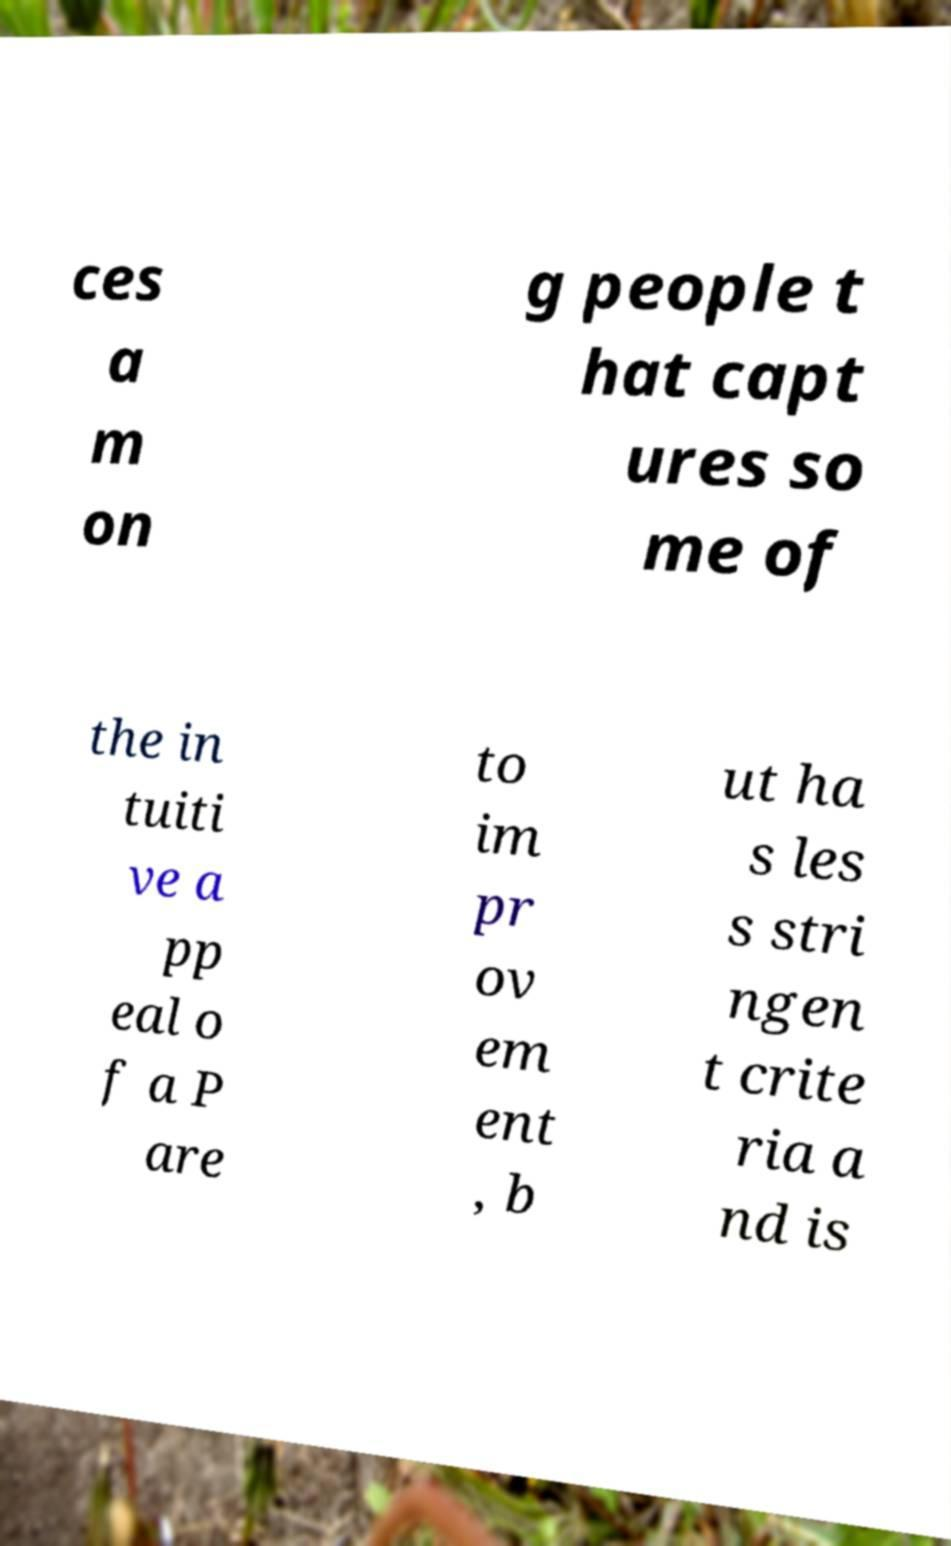Please identify and transcribe the text found in this image. ces a m on g people t hat capt ures so me of the in tuiti ve a pp eal o f a P are to im pr ov em ent , b ut ha s les s stri ngen t crite ria a nd is 